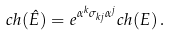<formula> <loc_0><loc_0><loc_500><loc_500>c h ( \hat { E } ) = e ^ { \alpha ^ { k } \sigma _ { k j } \alpha ^ { j } } c h ( E ) \, .</formula> 